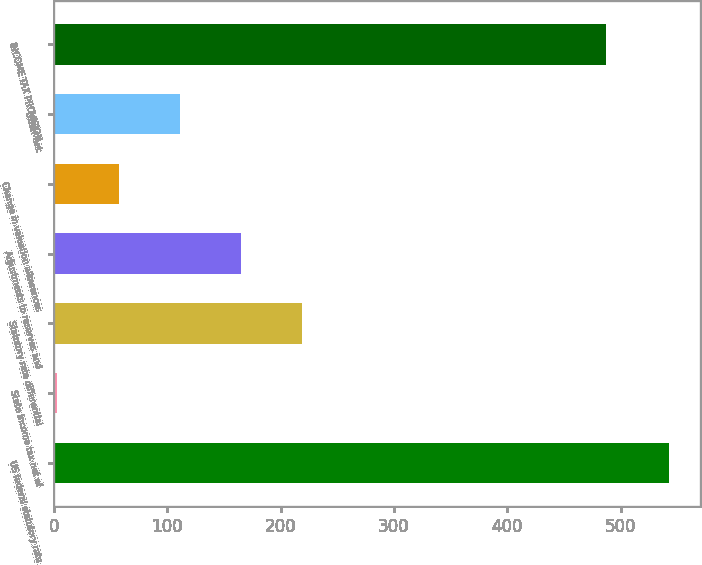Convert chart. <chart><loc_0><loc_0><loc_500><loc_500><bar_chart><fcel>US federal statutory rate<fcel>State income tax net of<fcel>Statutory rate differential<fcel>Adjustments to reserves and<fcel>Change in valuation allowances<fcel>Other net<fcel>INCOME TAX PROVISION<nl><fcel>543<fcel>3<fcel>219<fcel>165<fcel>57<fcel>111<fcel>487<nl></chart> 